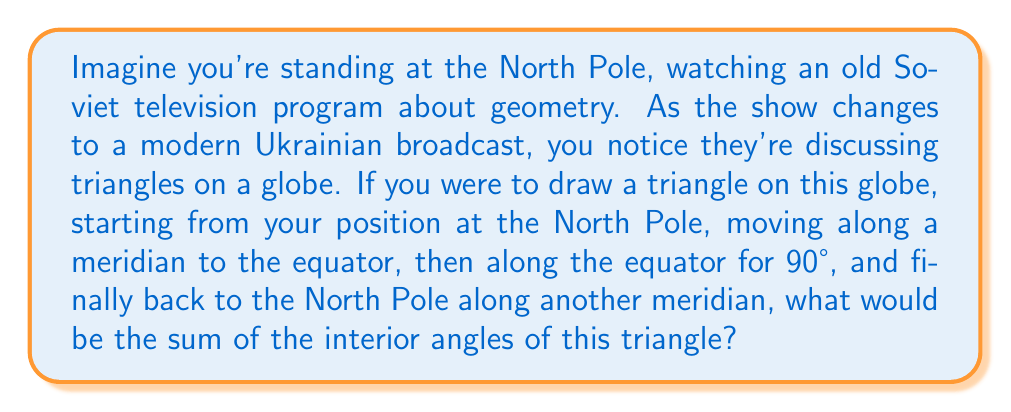Help me with this question. Let's approach this step-by-step:

1) In spherical geometry, the sum of angles in a triangle is always greater than 180°. The excess over 180° is proportional to the area of the triangle on the sphere's surface.

2) For our triangle:
   - At the North Pole, we have a 90° angle (right angle between meridians).
   - At the equator, we have a 90° angle (right angle between equator and meridian).
   - The third angle, where the equator meets the second meridian, is also 90°.

3) We can calculate this without needing to know the sphere's radius:

   $$\text{Sum of angles} = 90° + 90° + 90° = 270°$$

4) The excess over 180° is:

   $$270° - 180° = 90°$$

5) This excess of 90° corresponds to 1/4 of the earth's surface area (imagine the triangle covers 1/4 of the earth's surface).

6) In general, for a sphere, the sum of angles $\theta$ in a triangle is given by:

   $$\theta = 180° + \frac{A}{R^2} \cdot \frac{180°}{\pi}$$

   Where $A$ is the area of the triangle and $R$ is the radius of the sphere.

7) In our case, this formula gives us 270°, confirming our direct calculation.
Answer: 270° 